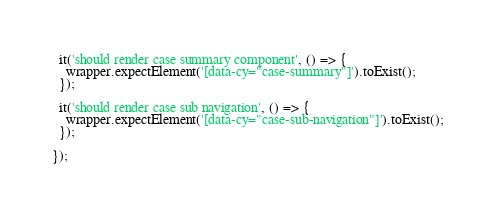<code> <loc_0><loc_0><loc_500><loc_500><_JavaScript_>
  it('should render case summary component', () => {
    wrapper.expectElement('[data-cy="case-summary"]').toExist();
  });

  it('should render case sub navigation', () => {
    wrapper.expectElement('[data-cy="case-sub-navigation"]').toExist();
  });

});
</code> 